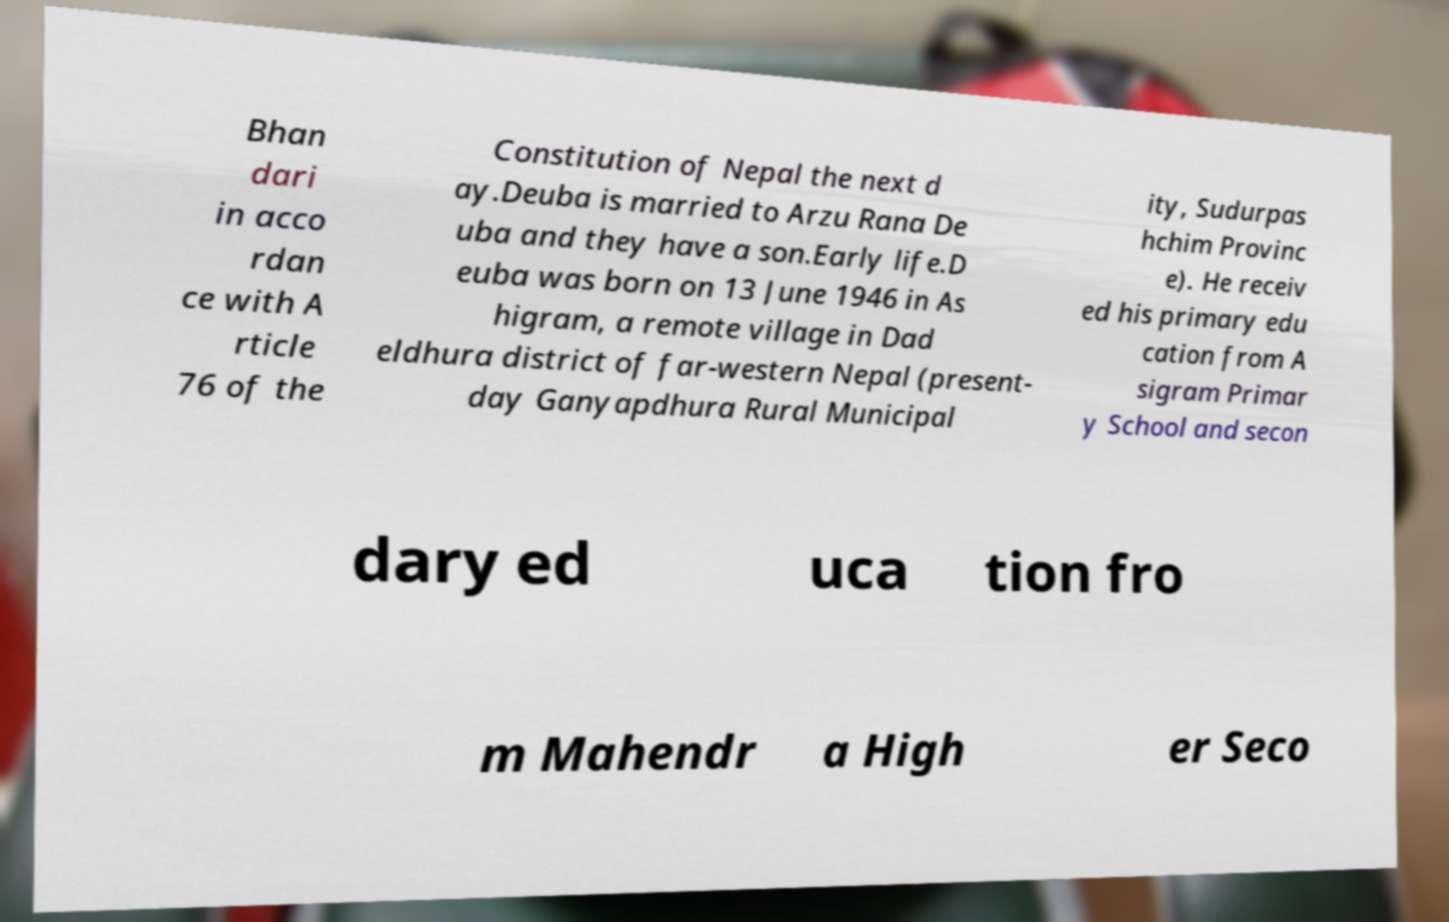Please identify and transcribe the text found in this image. Bhan dari in acco rdan ce with A rticle 76 of the Constitution of Nepal the next d ay.Deuba is married to Arzu Rana De uba and they have a son.Early life.D euba was born on 13 June 1946 in As higram, a remote village in Dad eldhura district of far-western Nepal (present- day Ganyapdhura Rural Municipal ity, Sudurpas hchim Provinc e). He receiv ed his primary edu cation from A sigram Primar y School and secon dary ed uca tion fro m Mahendr a High er Seco 